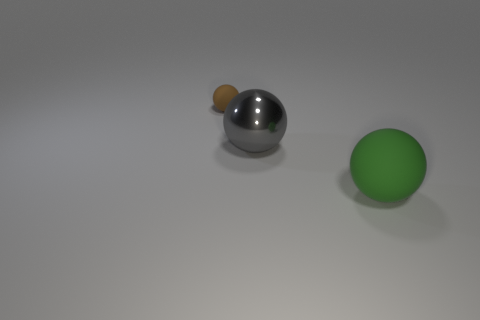Add 3 large green spheres. How many objects exist? 6 Add 2 large balls. How many large balls are left? 4 Add 3 big things. How many big things exist? 5 Subtract 0 blue cylinders. How many objects are left? 3 Subtract all big gray metal spheres. Subtract all big gray rubber blocks. How many objects are left? 2 